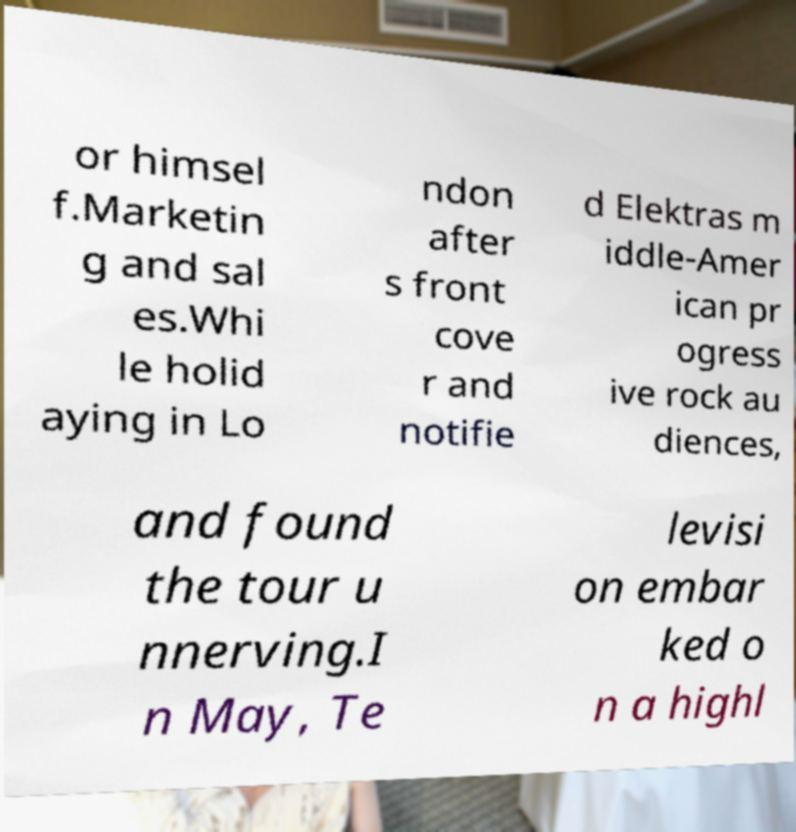For documentation purposes, I need the text within this image transcribed. Could you provide that? or himsel f.Marketin g and sal es.Whi le holid aying in Lo ndon after s front cove r and notifie d Elektras m iddle-Amer ican pr ogress ive rock au diences, and found the tour u nnerving.I n May, Te levisi on embar ked o n a highl 